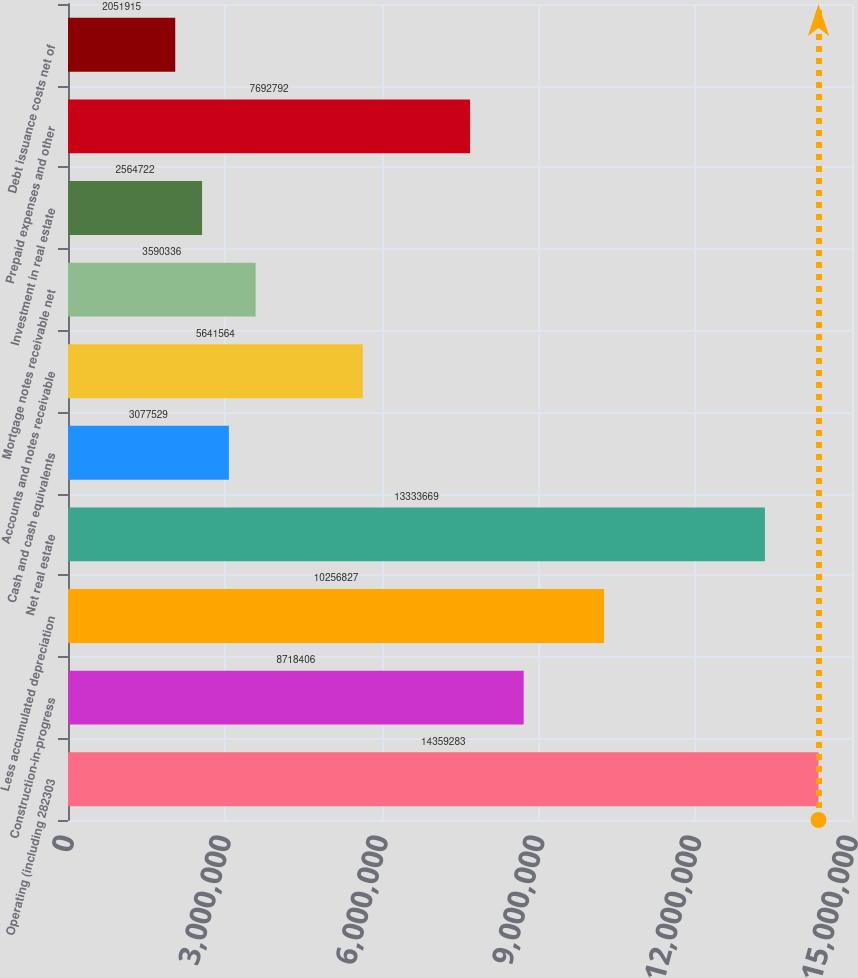Convert chart to OTSL. <chart><loc_0><loc_0><loc_500><loc_500><bar_chart><fcel>Operating (including 282303<fcel>Construction-in-progress<fcel>Less accumulated depreciation<fcel>Net real estate<fcel>Cash and cash equivalents<fcel>Accounts and notes receivable<fcel>Mortgage notes receivable net<fcel>Investment in real estate<fcel>Prepaid expenses and other<fcel>Debt issuance costs net of<nl><fcel>1.43593e+07<fcel>8.71841e+06<fcel>1.02568e+07<fcel>1.33337e+07<fcel>3.07753e+06<fcel>5.64156e+06<fcel>3.59034e+06<fcel>2.56472e+06<fcel>7.69279e+06<fcel>2.05192e+06<nl></chart> 